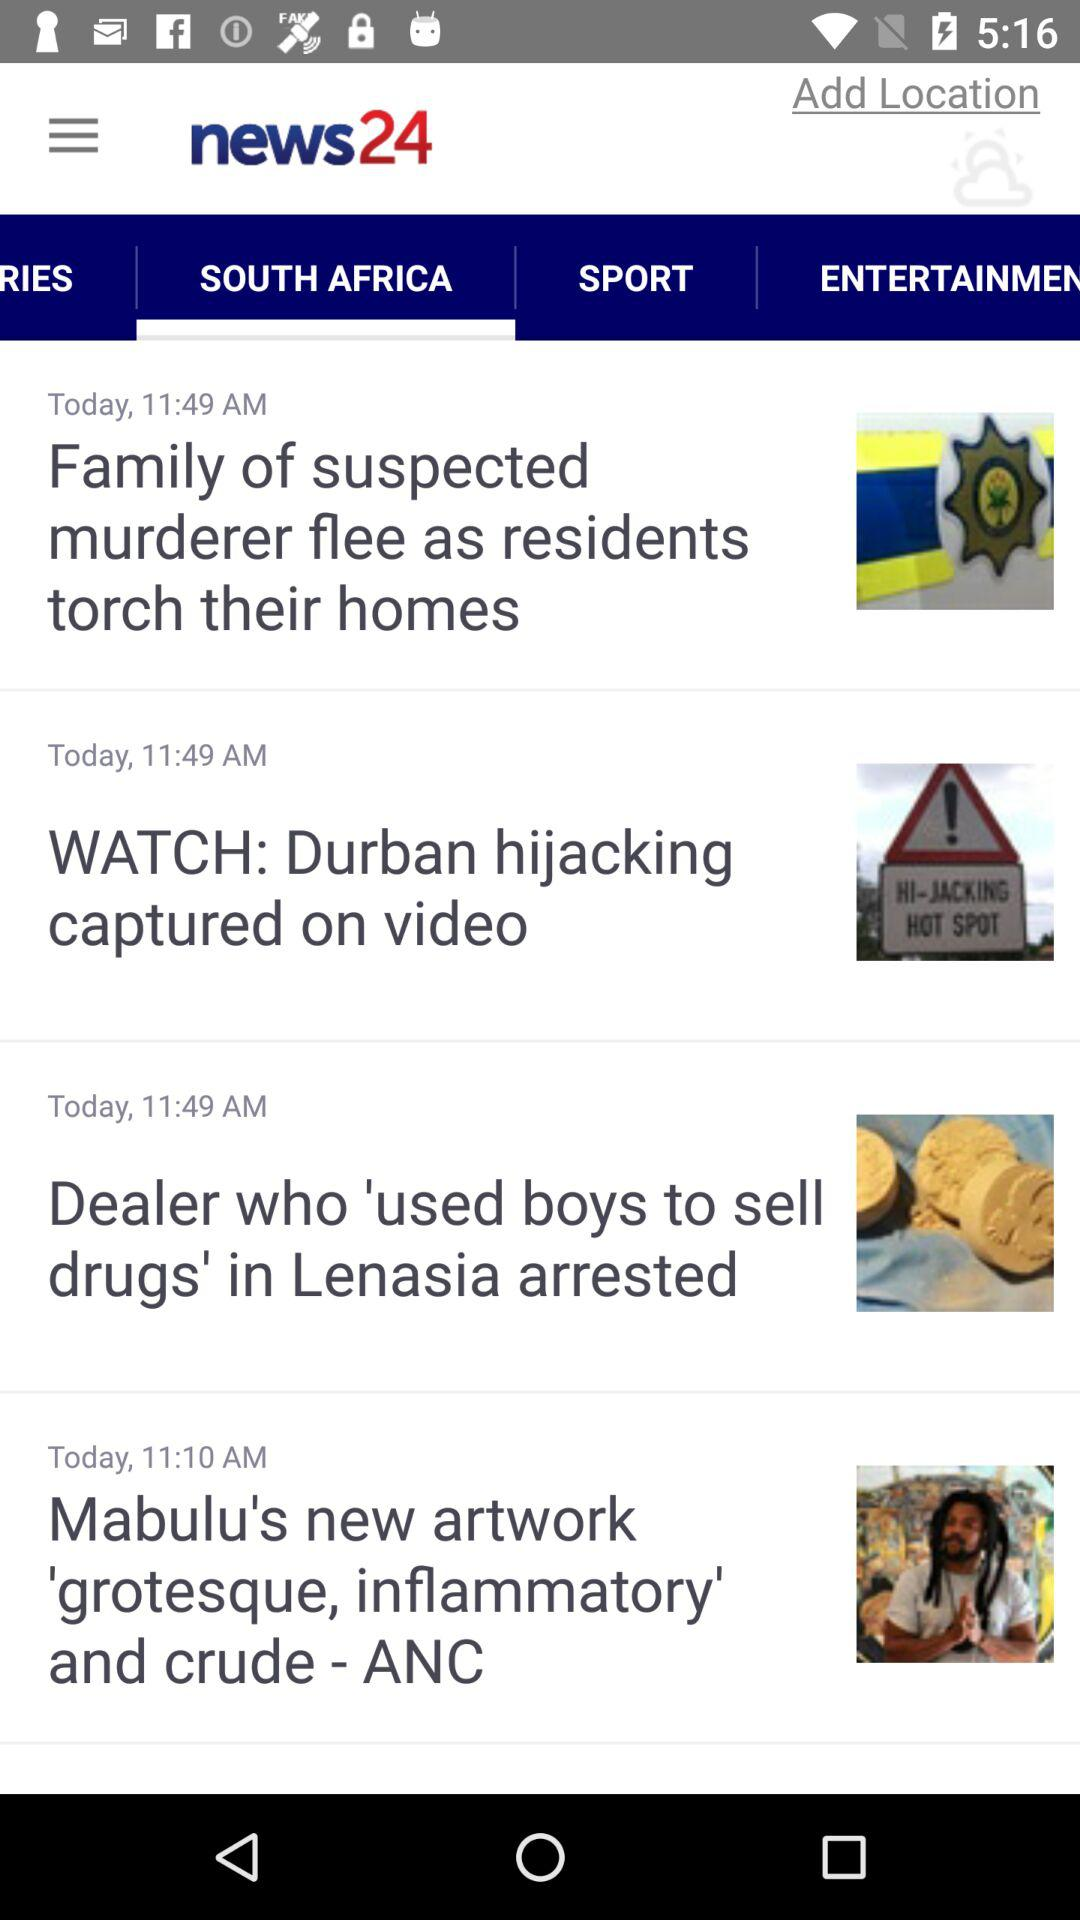How many news items are displayed on the screen?
Answer the question using a single word or phrase. 4 